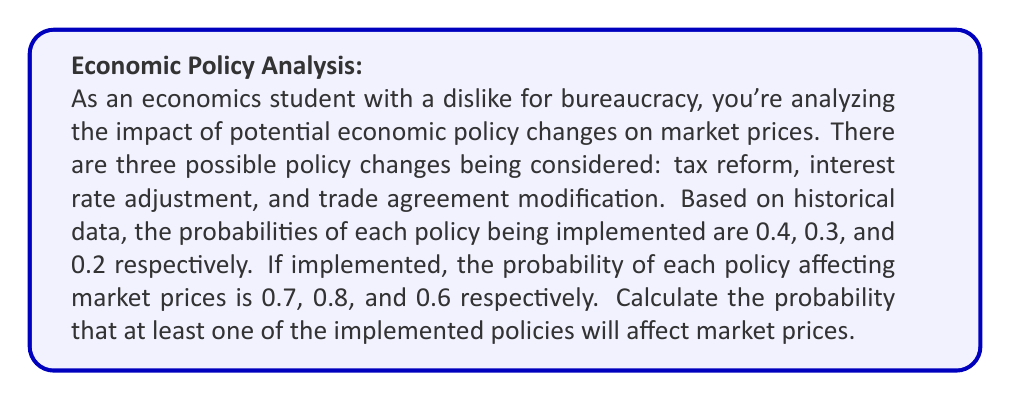Can you solve this math problem? Let's approach this step-by-step using the concept of probability of complementary events.

1) First, let's define our events:
   A: Tax reform is implemented and affects market prices
   B: Interest rate adjustment is implemented and affects market prices
   C: Trade agreement modification is implemented and affects market prices

2) We need to find P(at least one policy affects prices) = 1 - P(no policy affects prices)

3) For each policy, the probability that it doesn't affect prices is:
   P(A') = 1 - (0.4 * 0.7) = 0.72
   P(B') = 1 - (0.3 * 0.8) = 0.76
   P(C') = 1 - (0.2 * 0.6) = 0.88

4) The probability that none of the policies affect prices is the product of these probabilities:
   P(no policy affects prices) = P(A' and B' and C') = 0.72 * 0.76 * 0.88

5) Therefore, the probability that at least one policy affects prices is:
   P(at least one policy affects prices) = 1 - P(no policy affects prices)
   $$ = 1 - (0.72 * 0.76 * 0.88) $$
   $$ = 1 - 0.48193536 $$
   $$ = 0.51806464 $$

6) Rounding to four decimal places:
   $$ P(\text{at least one policy affects prices}) \approx 0.5181 $$
Answer: The probability that at least one of the implemented policies will affect market prices is approximately 0.5181 or 51.81%. 